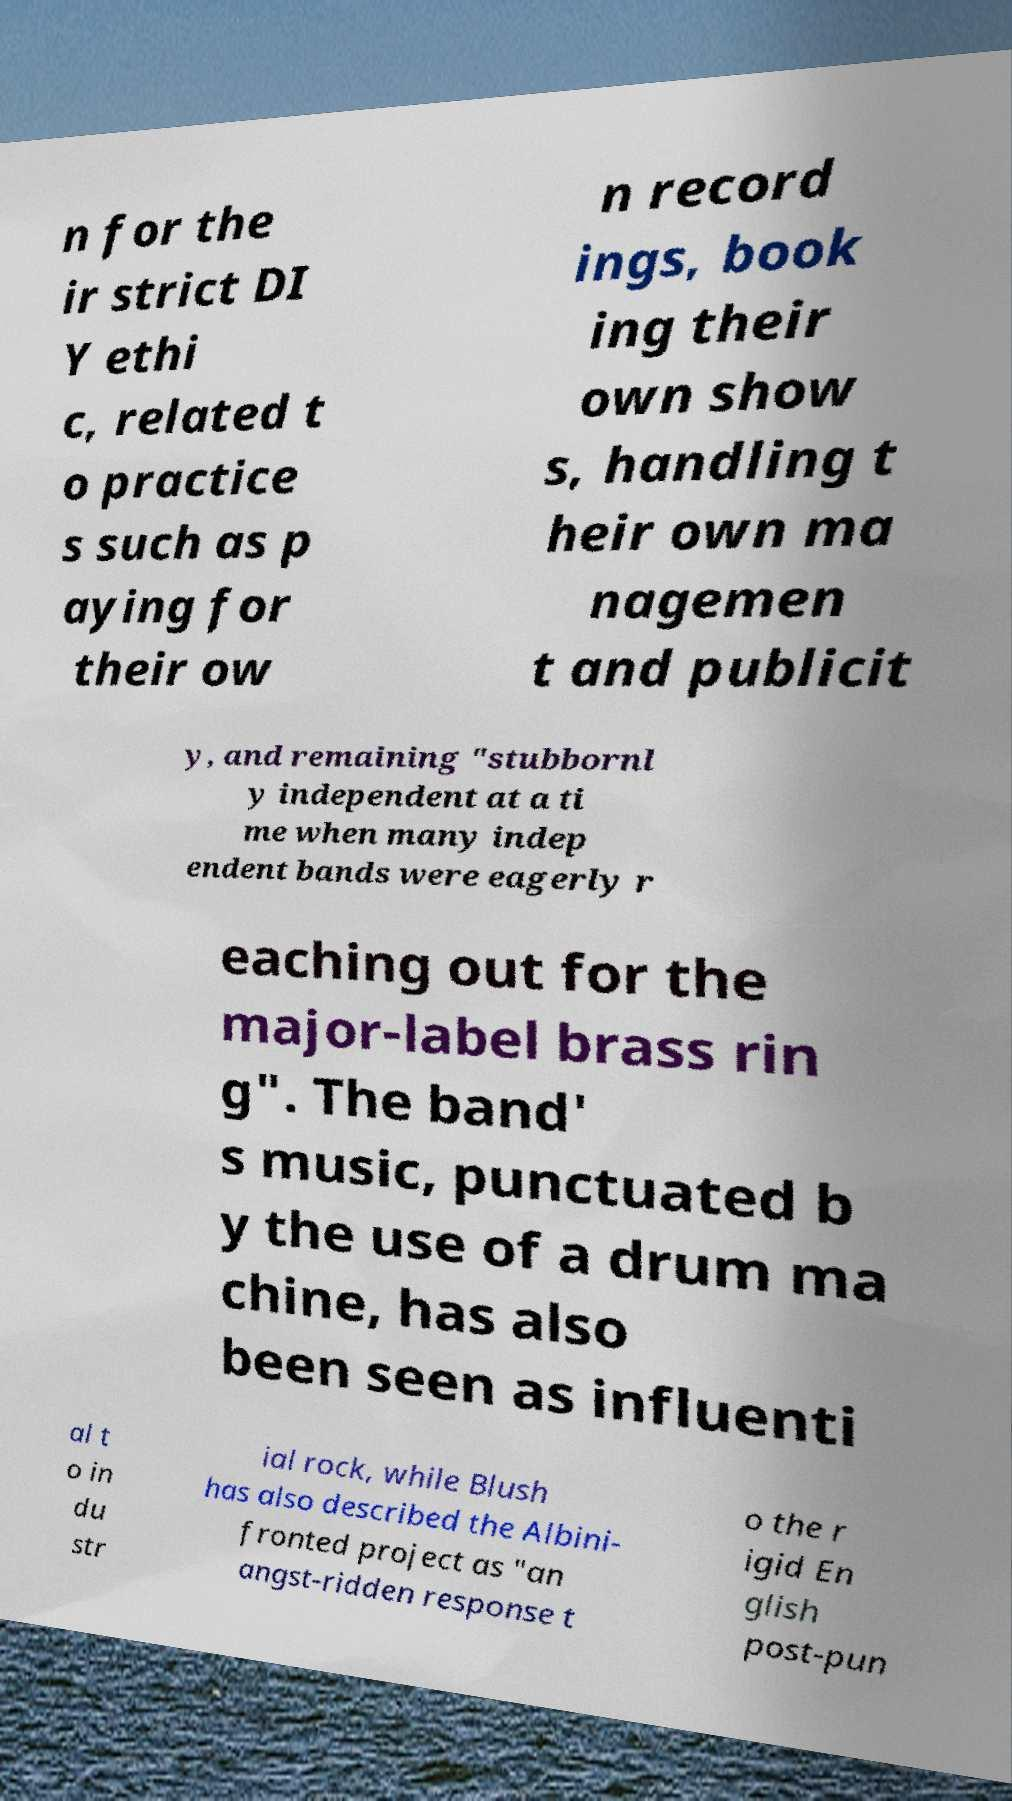Please identify and transcribe the text found in this image. n for the ir strict DI Y ethi c, related t o practice s such as p aying for their ow n record ings, book ing their own show s, handling t heir own ma nagemen t and publicit y, and remaining "stubbornl y independent at a ti me when many indep endent bands were eagerly r eaching out for the major-label brass rin g". The band' s music, punctuated b y the use of a drum ma chine, has also been seen as influenti al t o in du str ial rock, while Blush has also described the Albini- fronted project as "an angst-ridden response t o the r igid En glish post-pun 